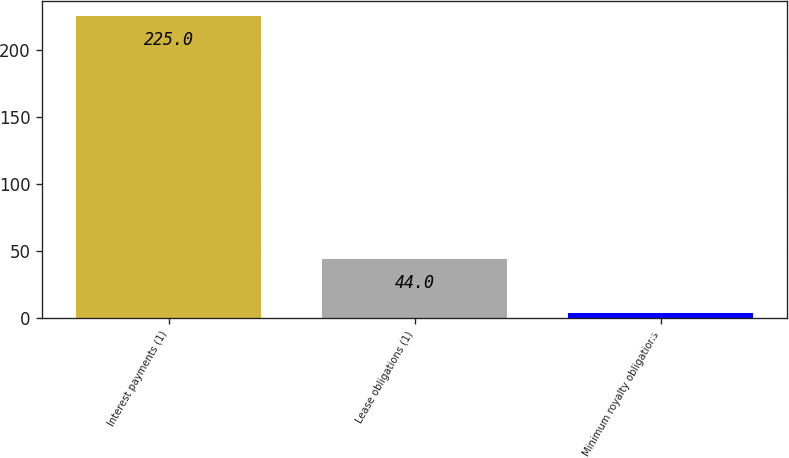Convert chart. <chart><loc_0><loc_0><loc_500><loc_500><bar_chart><fcel>Interest payments (1)<fcel>Lease obligations (1)<fcel>Minimum royalty obligations<nl><fcel>225<fcel>44<fcel>4<nl></chart> 